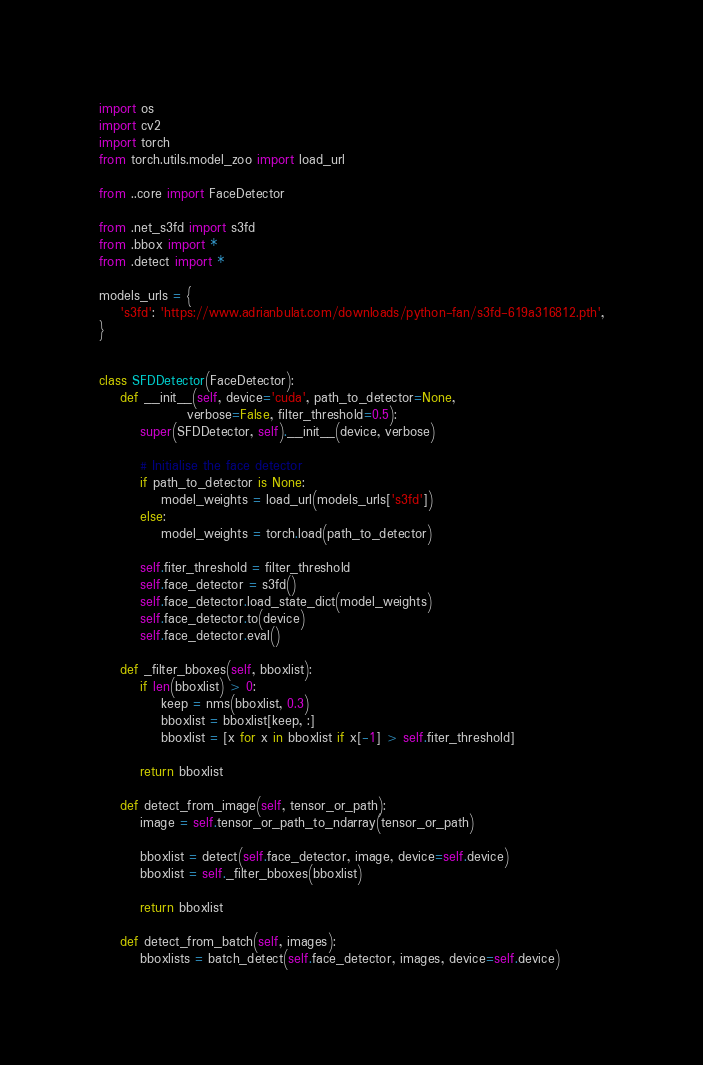Convert code to text. <code><loc_0><loc_0><loc_500><loc_500><_Python_>import os
import cv2
import torch
from torch.utils.model_zoo import load_url

from ..core import FaceDetector

from .net_s3fd import s3fd
from .bbox import *
from .detect import *

models_urls = {
    's3fd': 'https://www.adrianbulat.com/downloads/python-fan/s3fd-619a316812.pth',
}


class SFDDetector(FaceDetector):
    def __init__(self, device='cuda', path_to_detector=None, 
                 verbose=False, filter_threshold=0.5):
        super(SFDDetector, self).__init__(device, verbose)

        # Initialise the face detector
        if path_to_detector is None:
            model_weights = load_url(models_urls['s3fd'])
        else:
            model_weights = torch.load(path_to_detector)

        self.fiter_threshold = filter_threshold
        self.face_detector = s3fd()
        self.face_detector.load_state_dict(model_weights)
        self.face_detector.to(device)
        self.face_detector.eval()

    def _filter_bboxes(self, bboxlist):
        if len(bboxlist) > 0:
            keep = nms(bboxlist, 0.3)
            bboxlist = bboxlist[keep, :]
            bboxlist = [x for x in bboxlist if x[-1] > self.fiter_threshold]

        return bboxlist

    def detect_from_image(self, tensor_or_path):
        image = self.tensor_or_path_to_ndarray(tensor_or_path)

        bboxlist = detect(self.face_detector, image, device=self.device)
        bboxlist = self._filter_bboxes(bboxlist)

        return bboxlist

    def detect_from_batch(self, images):
        bboxlists = batch_detect(self.face_detector, images, device=self.device)</code> 